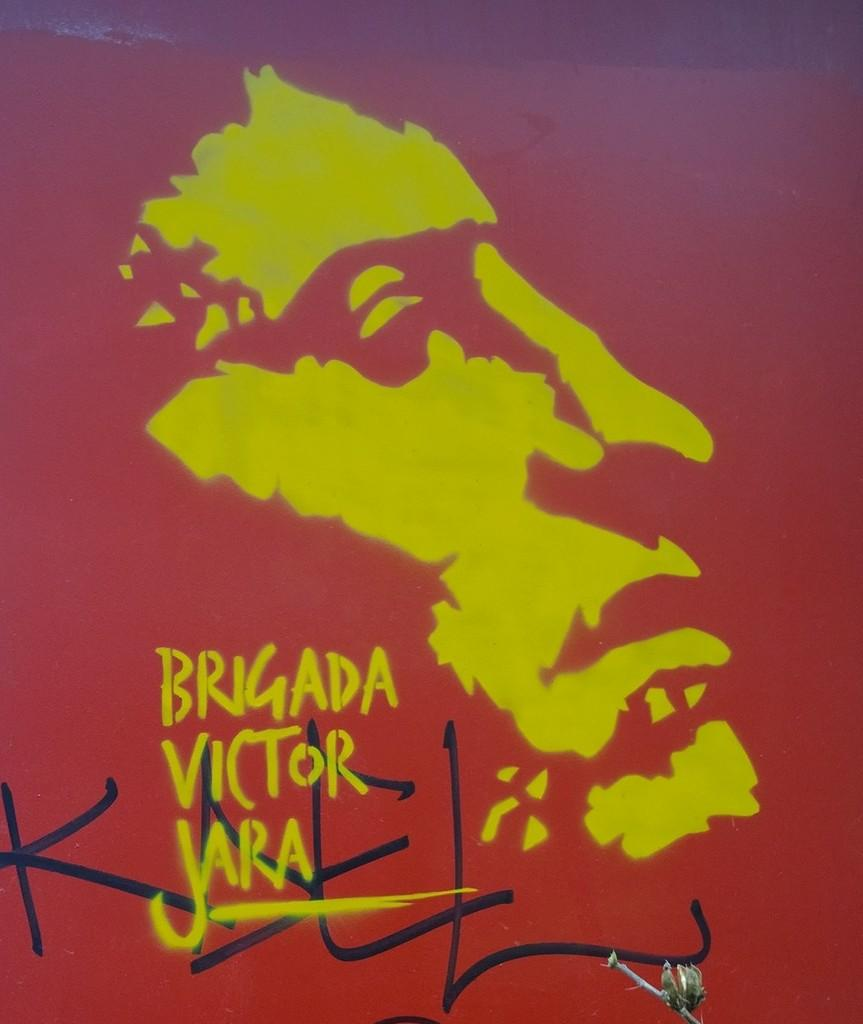What type of image is depicted in the poster? The image is a poster. What is the main subject of the poster? There is a painting of a person on the poster. Are there any words on the poster? Yes, there is text on the poster. What type of pickle is featured in the painting on the poster? There is no pickle present in the painting on the poster; it features a person. How does the person in the painting react to the pickle? There is no pickle in the painting, so the person's reaction to a pickle cannot be determined. 